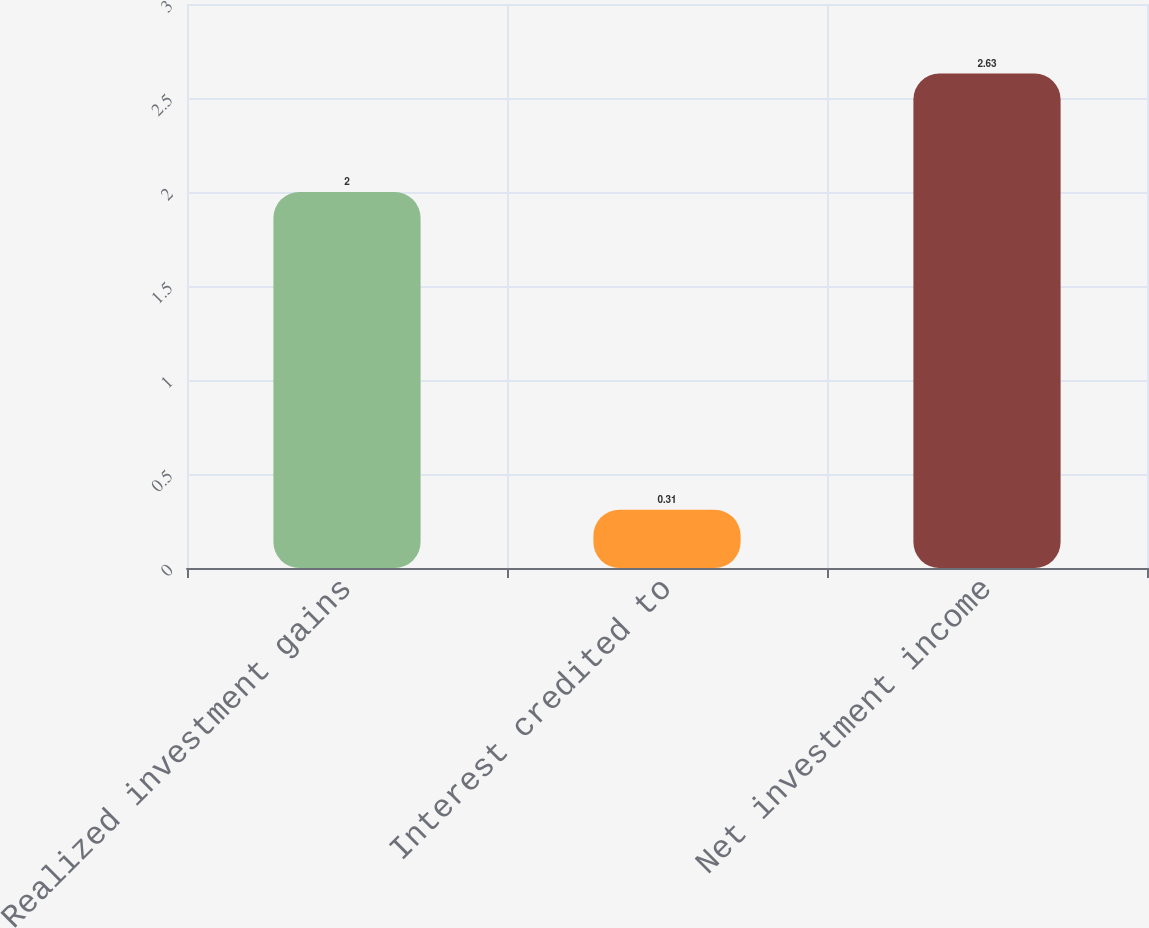Convert chart to OTSL. <chart><loc_0><loc_0><loc_500><loc_500><bar_chart><fcel>Realized investment gains<fcel>Interest credited to<fcel>Net investment income<nl><fcel>2<fcel>0.31<fcel>2.63<nl></chart> 